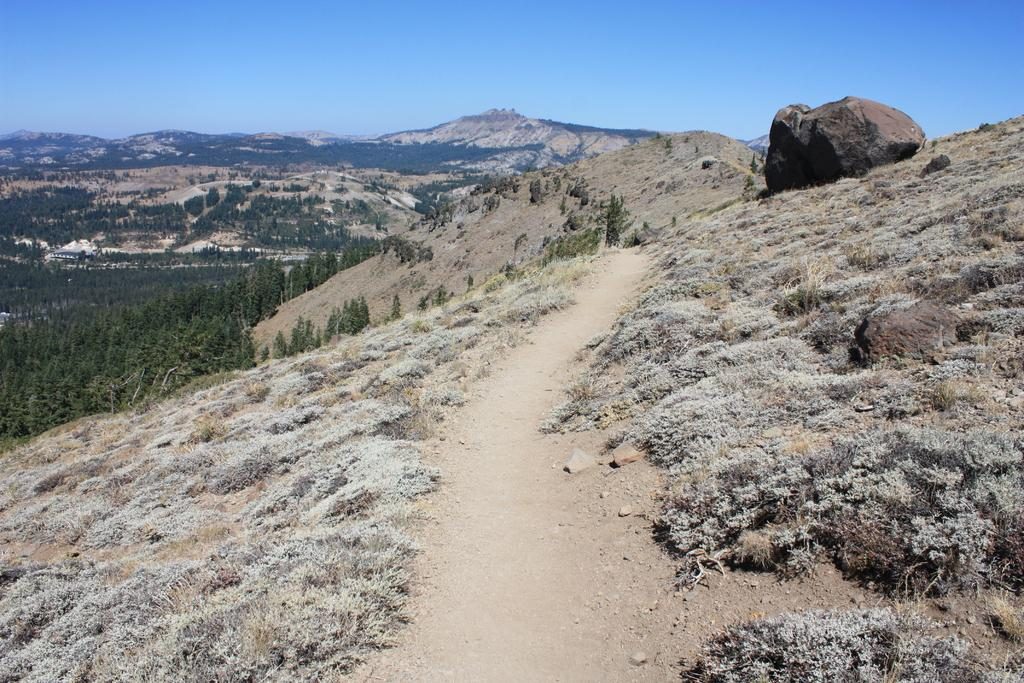What type of path is visible in the image? There is a walkway in the image. What other natural elements can be seen in the image? There are plants and rocks visible in the image. What can be seen in the background of the image? There are trees, hills, and the sky visible in the background of the image. What type of attraction is present in the image? There is no specific attraction mentioned or visible in the image; it features a walkway, plants, rocks, trees, hills, and the sky. 